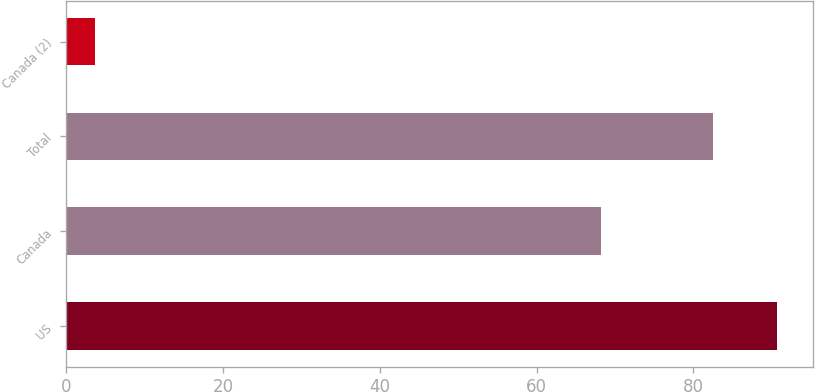<chart> <loc_0><loc_0><loc_500><loc_500><bar_chart><fcel>US<fcel>Canada<fcel>Total<fcel>Canada (2)<nl><fcel>90.67<fcel>68.14<fcel>82.47<fcel>3.64<nl></chart> 